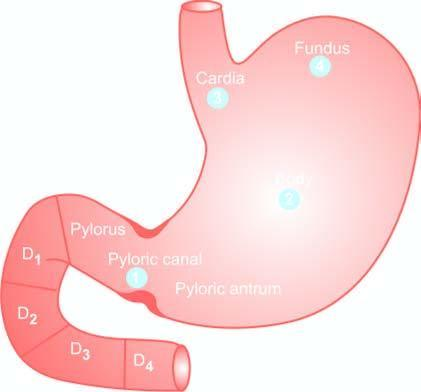what do the serial numbers in the figure indicate?
Answer the question using a single word or phrase. Order of frequency of occurrence of gastric cancer 